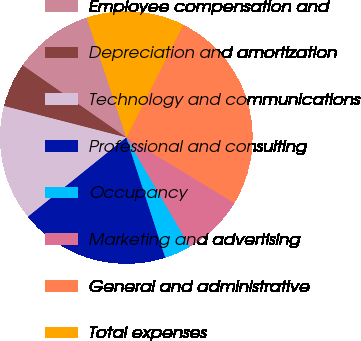<chart> <loc_0><loc_0><loc_500><loc_500><pie_chart><fcel>Employee compensation and<fcel>Depreciation and amortization<fcel>Technology and communications<fcel>Professional and consulting<fcel>Occupancy<fcel>Marketing and advertising<fcel>General and administrative<fcel>Total expenses<nl><fcel>10.24%<fcel>5.67%<fcel>14.8%<fcel>19.2%<fcel>3.39%<fcel>7.95%<fcel>26.22%<fcel>12.52%<nl></chart> 